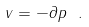Convert formula to latex. <formula><loc_0><loc_0><loc_500><loc_500>v = - \partial p \ .</formula> 